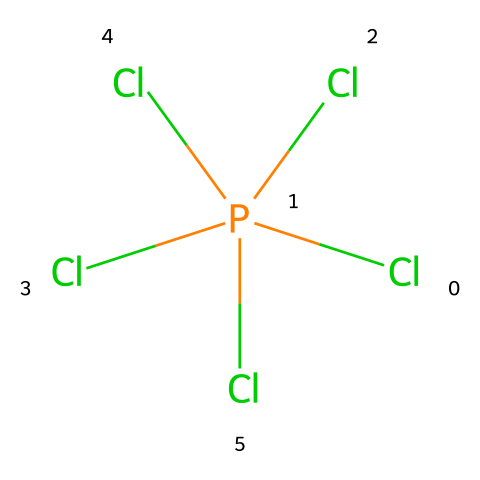What is the molecular formula of the compound? The compound has one phosphorus atom and five chlorine atoms, which gives it the molecular formula PCl5.
Answer: PCl5 How many chlorine atoms are connected to phosphorus? The visual representation shows five chlorine atoms connected to the phosphorus atom, indicating that phosphorus is surrounded by five chlorine atoms.
Answer: five Is phosphorus in a hypervalent state in this compound? In PCl5, phosphorus has five bonds, which exceeds the typical valency (three) for phosphorus, thus placing it in a hypervalent state.
Answer: yes What type of bonds are present in phosphorus pentachloride? The structure shows single covalent bonds between phosphorus and each chlorine atom, confirming that phosphorus pentachloride consists of single bonds.
Answer: single Why does phosphorus pentachloride act as a flame retardant? The presence of chlorine atoms contributes to phosphorus pentachloride’s ability to inhibit combustion, allowing it to serve as an effective flame retardant by releasing chlorine free radicals during thermal decomposition.
Answer: inhibits combustion How does the molecular arrangement affect its reactivity? The arrangement allows for strong interaction with other chemicals, as the hypervalent nature and geometry of phosphorus pentachloride lead to unique reactivity patterns compared to non-hypervalent compounds.
Answer: unique reactivity What is the bond angle in phosphorus pentachloride? The geometry of phosphorus pentachloride is trigonal bipyramidal, indicating that the bond angles between the equatorial chlorines are 120 degrees, while the axial chlorines are 180 degrees apart.
Answer: 120 degrees and 180 degrees 